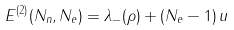<formula> <loc_0><loc_0><loc_500><loc_500>E ^ { ( 2 ) } ( N _ { n } , N _ { e } ) = \lambda _ { - } ( \rho ) + ( N _ { e } - 1 ) \, u</formula> 